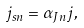<formula> <loc_0><loc_0><loc_500><loc_500>j _ { s n } = \alpha _ { J n } j ,</formula> 